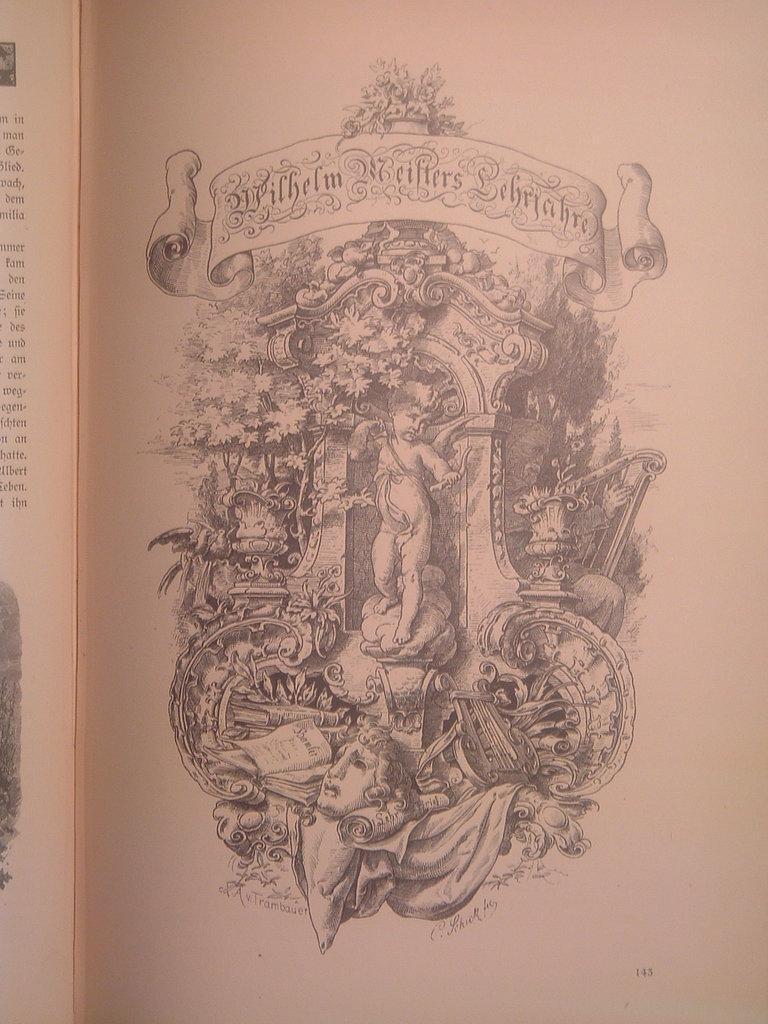In one or two sentences, can you explain what this image depicts? In this image we can see a picture on the paper. On the left side of the image there is a text on the paper. 